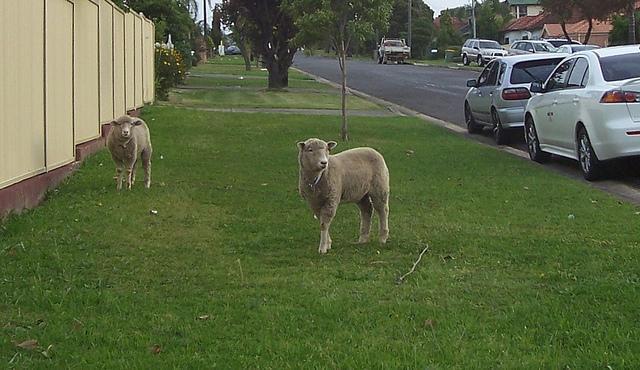How many cars can be seen?
Give a very brief answer. 7. How many sheep can be seen?
Give a very brief answer. 2. How many cars are there?
Give a very brief answer. 2. How many people are here?
Give a very brief answer. 0. 